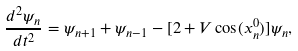Convert formula to latex. <formula><loc_0><loc_0><loc_500><loc_500>\frac { d ^ { 2 } \psi _ { n } } { d t ^ { 2 } } = \psi _ { n + 1 } + \psi _ { n - 1 } - [ 2 + V \cos ( x _ { n } ^ { 0 } ) ] \psi _ { n } ,</formula> 